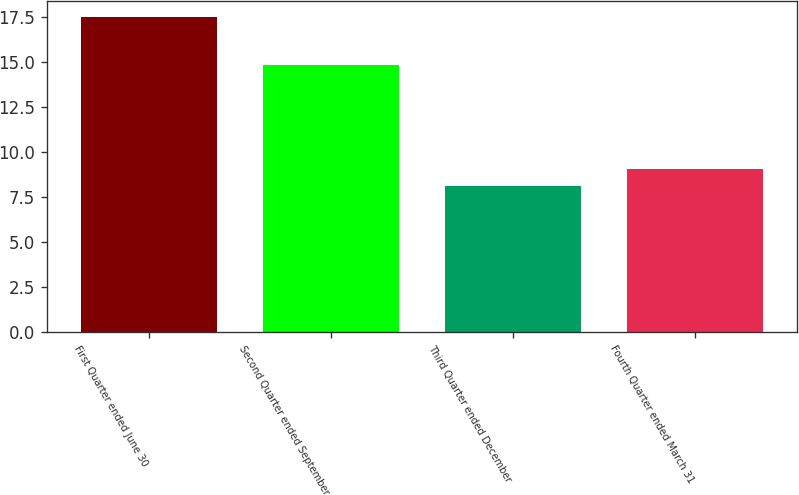Convert chart. <chart><loc_0><loc_0><loc_500><loc_500><bar_chart><fcel>First Quarter ended June 30<fcel>Second Quarter ended September<fcel>Third Quarter ended December<fcel>Fourth Quarter ended March 31<nl><fcel>17.55<fcel>14.87<fcel>8.13<fcel>9.07<nl></chart> 